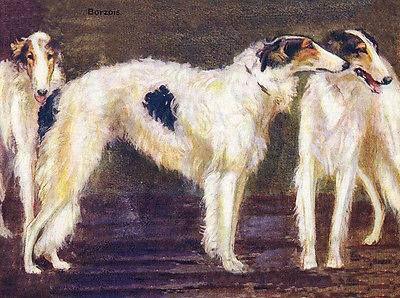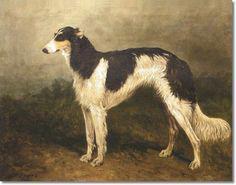The first image is the image on the left, the second image is the image on the right. For the images displayed, is the sentence "At least one dog has its mouth open." factually correct? Answer yes or no. Yes. 